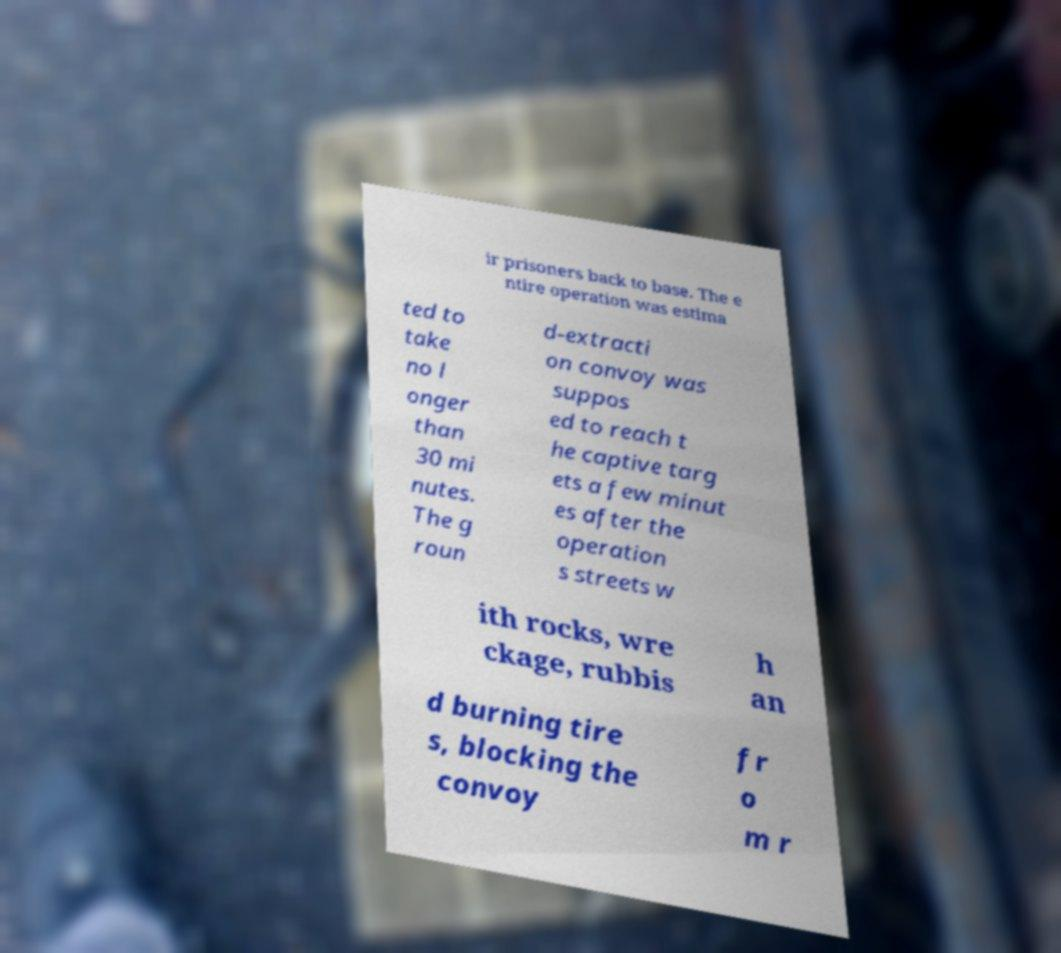Could you assist in decoding the text presented in this image and type it out clearly? ir prisoners back to base. The e ntire operation was estima ted to take no l onger than 30 mi nutes. The g roun d-extracti on convoy was suppos ed to reach t he captive targ ets a few minut es after the operation s streets w ith rocks, wre ckage, rubbis h an d burning tire s, blocking the convoy fr o m r 